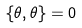<formula> <loc_0><loc_0><loc_500><loc_500>\{ \theta , \theta \} = 0</formula> 